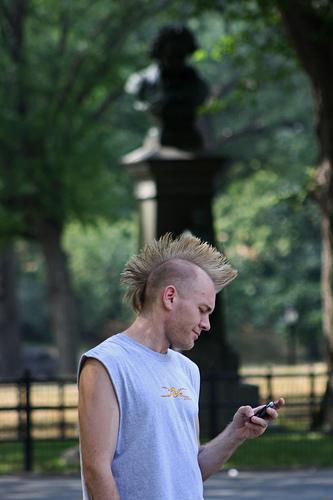How many men are in the picture?
Give a very brief answer. 1. 